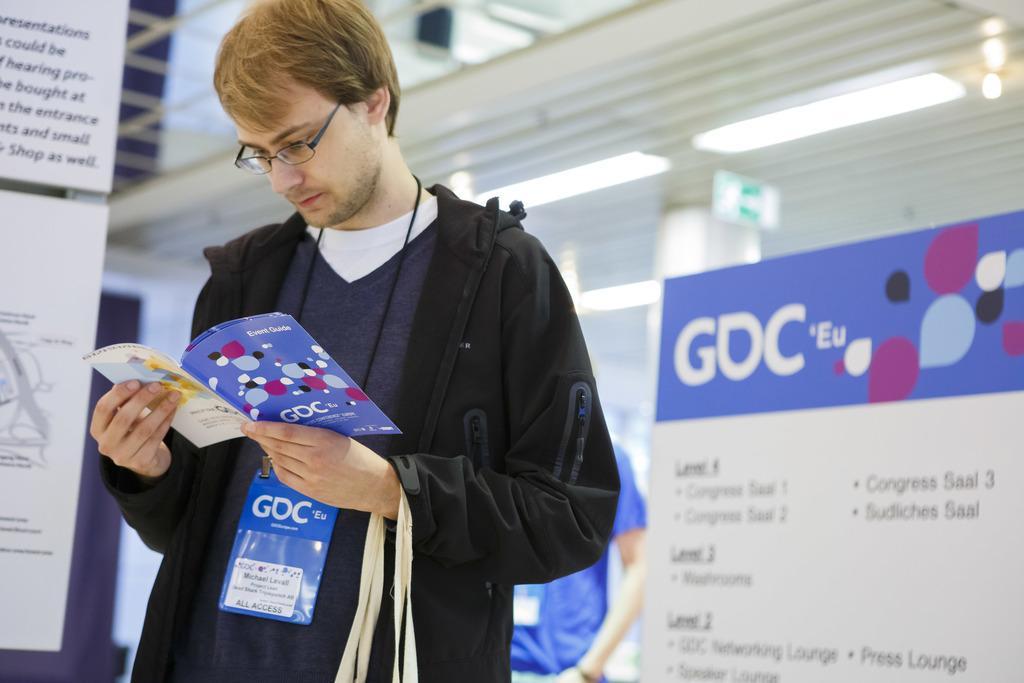How would you summarize this image in a sentence or two? In this image, I can see a person standing and holding a book. On the left and right side of the image, I can see the boards. In the background, there is another person standing and lights attached to the ceiling. 